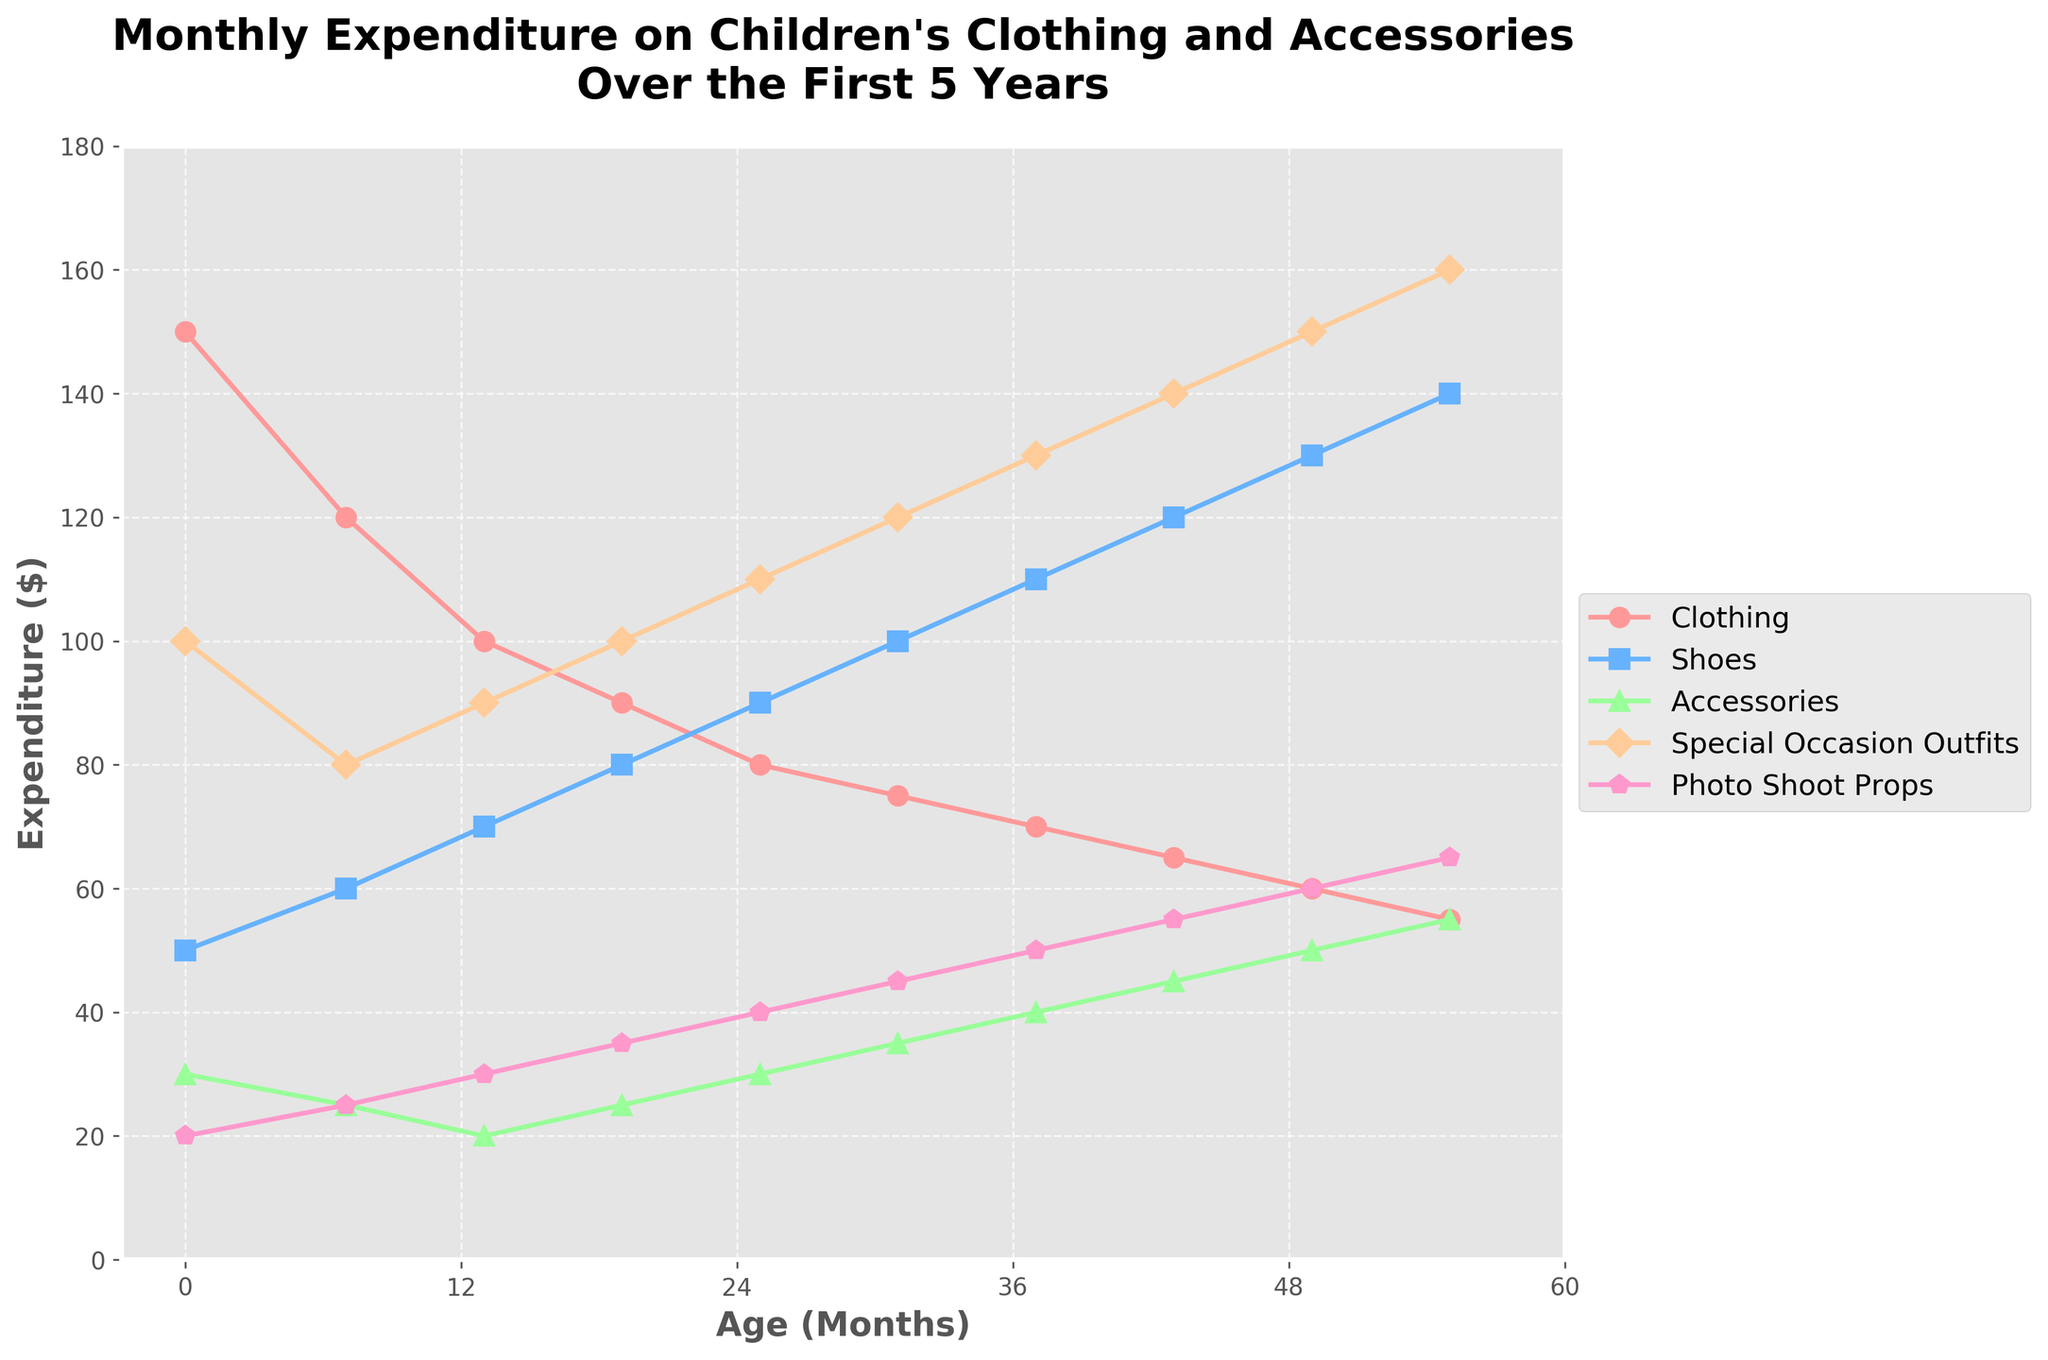What's the highest expenditure category for 0-6 months old? To determine the highest expenditure category, look at the data points for the 0-6 months age group. Compare the values for Clothing ($150), Shoes ($50), Accessories ($30), Special Occasion Outfits ($100), and Photo Shoot Props ($20). The highest value is Clothing ($150).
Answer: Clothing Which age group spends equally on Accessories and Shoes? Compare the values for Accessories and Shoes across all age groups. The one where the values are equal is 55-60 months with Accessories at $55 and Shoes at $140.
Answer: None What is the total expenditure on Photo Shoot Props over the first 5 years? To find the total expenditure, sum up the values across all age groups: 20 + 25 + 30 + 35 + 40 + 45 + 50 + 55 + 60 + 65 = 425.
Answer: $425 At what age does expenditure on Special Occasion Outfits first surpass expenditure on Clothing? Compare the expenditure on Special Occasion Outfits and Clothing across each age group. This surpasses at age 31-36 months where Special Occasion Outfits are $120 while Clothing is $75.
Answer: 31-36 months Is the expenditure on Shoes always increasing as the child ages? Check each expenditure value for Shoes across all age groups to see if it is consistently rising: 
50, 60, 70, 80, 90, 100, 110, 120, 130, 140. Since all values are increasing, Shoes expenditure is always increasing.
Answer: Yes What's the combined expenditure on Accessories and Special Occasion Outfits for 19-24 months? Add the expense for Accessories ($25) and Special Occasion Outfits ($100) during 19-24 months. The combined expenditure is 25+100=125.
Answer: $125 